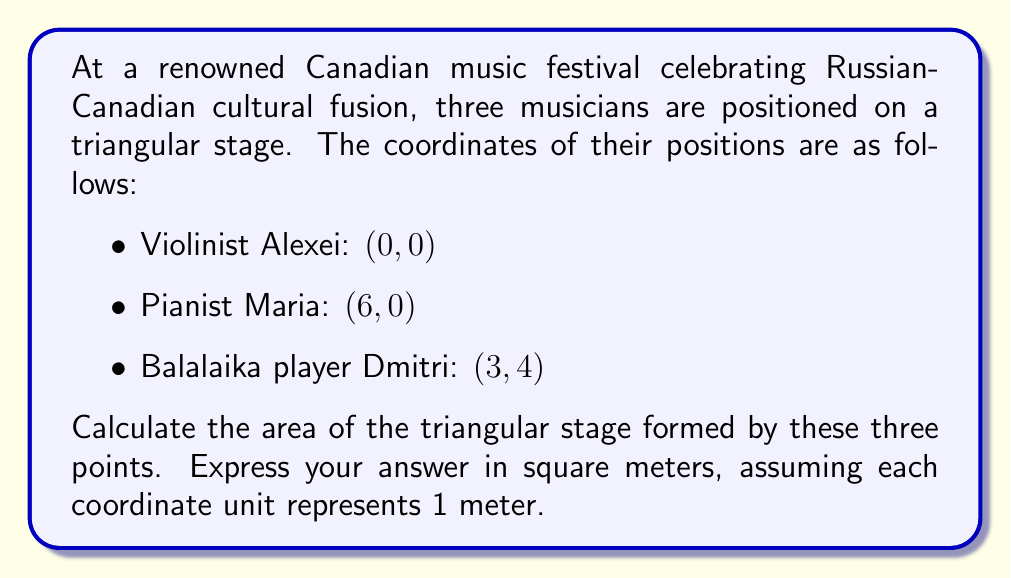Could you help me with this problem? To solve this problem, we'll use the formula for the area of a triangle given the coordinates of its vertices. This method is particularly useful in analytic geometry.

Let's denote the coordinates as:
$A(x_1, y_1) = (0, 0)$
$B(x_2, y_2) = (6, 0)$
$C(x_3, y_3) = (3, 4)$

The formula for the area of a triangle given three points is:

$$\text{Area} = \frac{1}{2}|x_1(y_2 - y_3) + x_2(y_3 - y_1) + x_3(y_1 - y_2)|$$

Let's substitute our values:

$$\begin{align*}
\text{Area} &= \frac{1}{2}|0(0 - 4) + 6(4 - 0) + 3(0 - 0)| \\
&= \frac{1}{2}|0 + 24 + 0| \\
&= \frac{1}{2}|24| \\
&= \frac{1}{2} \cdot 24 \\
&= 12
\end{align*}$$

Therefore, the area of the triangular stage is 12 square meters.

To visualize this, we can draw the triangle:

[asy]
unitsize(1cm);
pair A = (0,0);
pair B = (6,0);
pair C = (3,4);
draw(A--B--C--cycle);
dot("A (0,0)", A, SW);
dot("B (6,0)", B, SE);
dot("C (3,4)", C, N);
[/asy]

This diagram shows the triangular stage with the musicians positioned at the vertices.
Answer: 12 square meters 